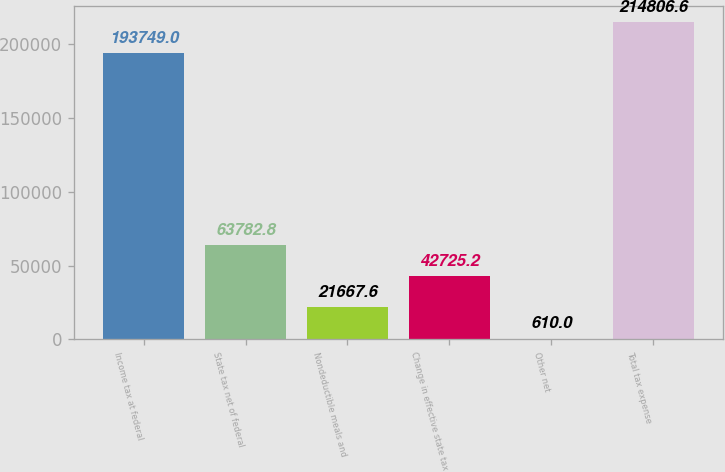Convert chart to OTSL. <chart><loc_0><loc_0><loc_500><loc_500><bar_chart><fcel>Income tax at federal<fcel>State tax net of federal<fcel>Nondeductible meals and<fcel>Change in effective state tax<fcel>Other net<fcel>Total tax expense<nl><fcel>193749<fcel>63782.8<fcel>21667.6<fcel>42725.2<fcel>610<fcel>214807<nl></chart> 